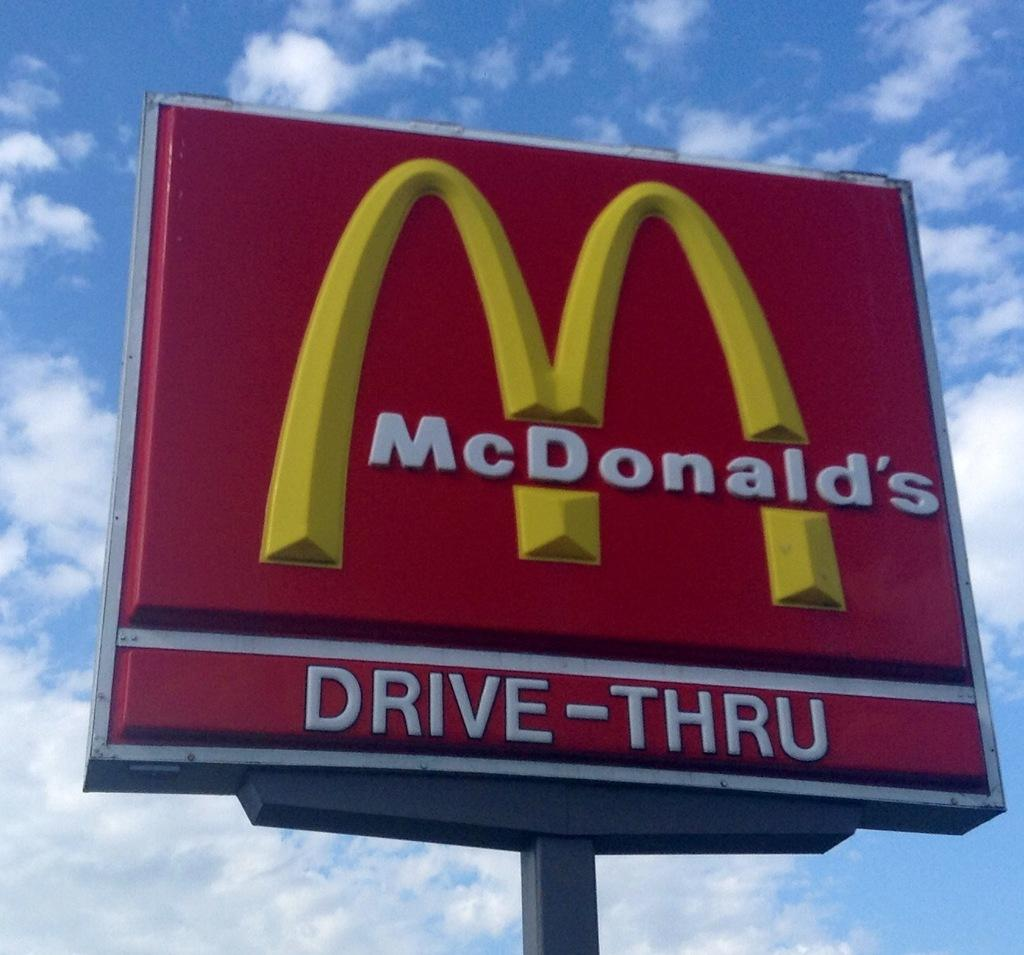What is the main object in the image? There is a name board in the image. What can be seen in the background of the image? The sky is visible in the background of the image. What is the condition of the sky in the image? Clouds are present in the sky. How many brothers are depicted with the name board in the image? There are no brothers depicted in the image; it only features a name board and clouds in the sky. 